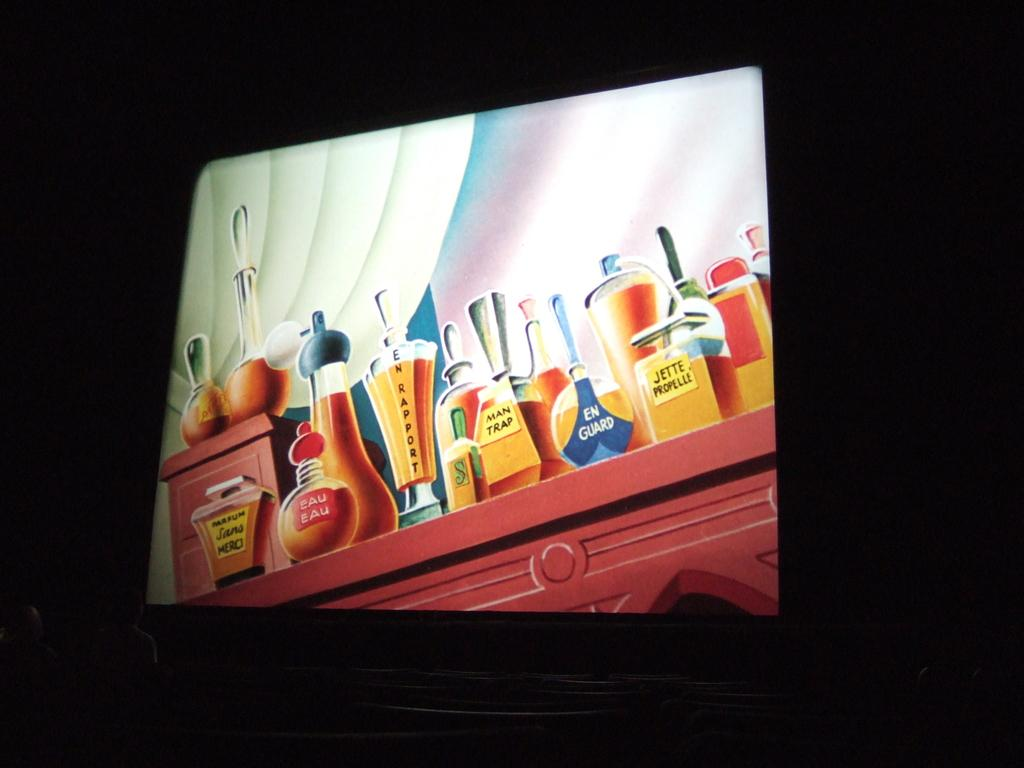<image>
Provide a brief description of the given image. a computer monitor open to a graphic display of bottles including EN GUARD and EAU EAU 